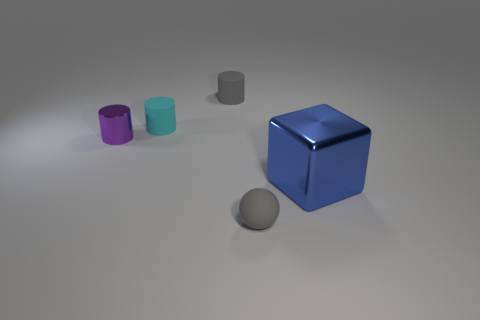Subtract all tiny rubber cylinders. How many cylinders are left? 1 Subtract all gray cylinders. How many cylinders are left? 2 Subtract all spheres. How many objects are left? 4 Subtract 1 balls. How many balls are left? 0 Add 1 large green rubber cylinders. How many objects exist? 6 Subtract all purple blocks. Subtract all brown cylinders. How many blocks are left? 1 Subtract all blue cubes. How many blue cylinders are left? 0 Subtract all cyan matte cubes. Subtract all metallic cylinders. How many objects are left? 4 Add 5 purple metallic things. How many purple metallic things are left? 6 Add 1 blue metal balls. How many blue metal balls exist? 1 